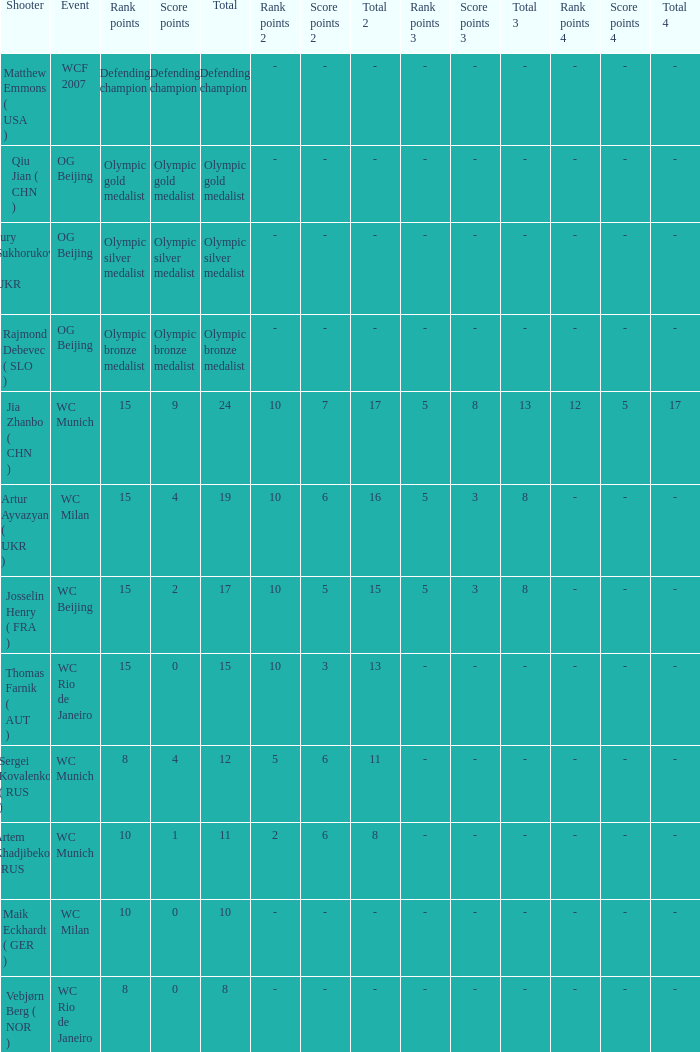With a total of 11, and 10 rank points, what are the score points? 1.0. 